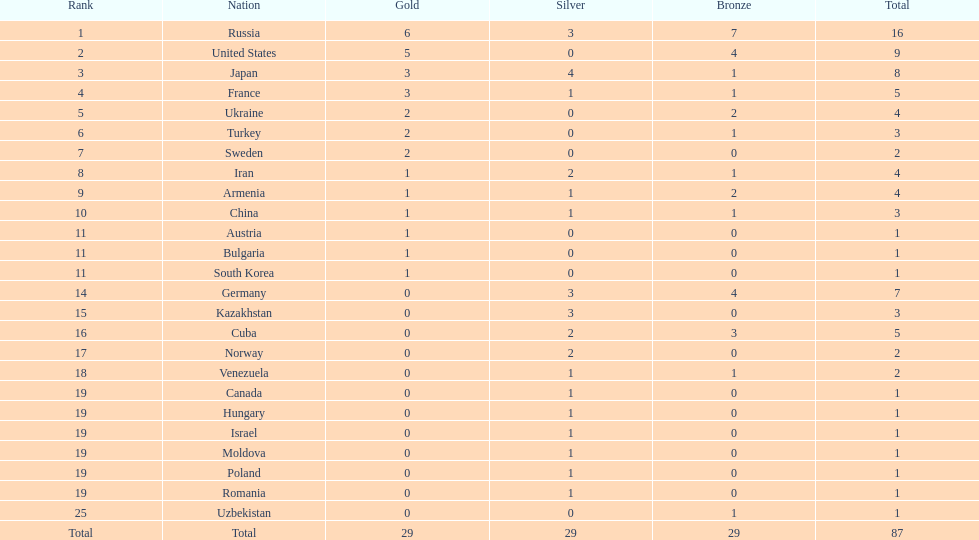Who won more gold medals than the united states? Russia. 